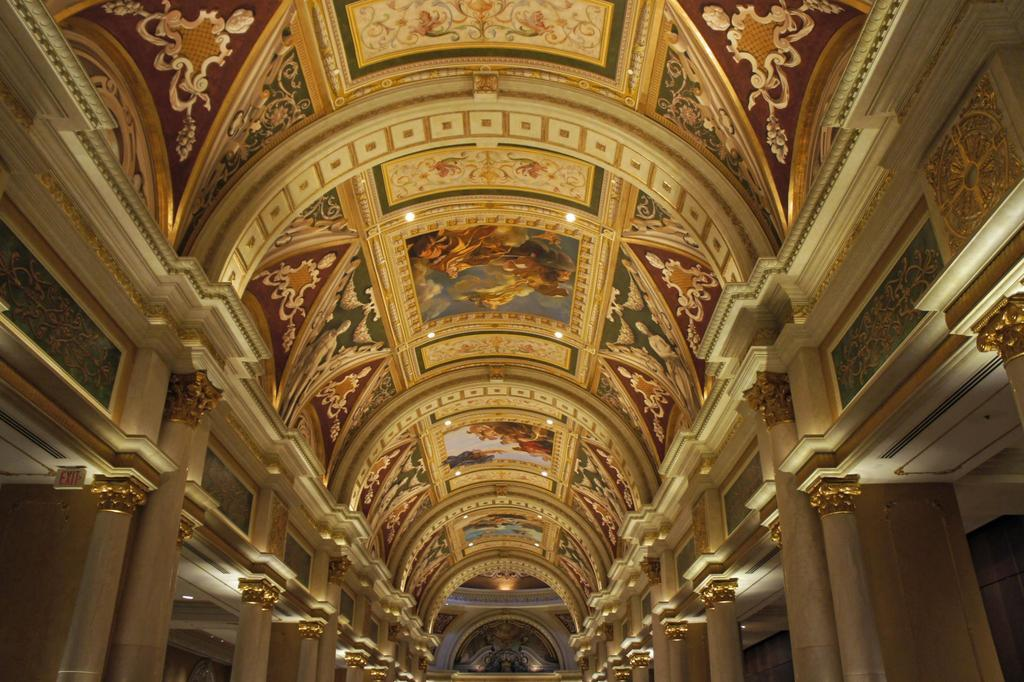What can be seen at the top of the image? There are lights visible at the top of the image. What is depicted on a wall in the image? There is a drawing on a wall in the image. What type of mountain is visible in the image? There is no mountain present in the image. What thoughts are being expressed by the drawing on the wall? The drawing on the wall does not express any thoughts, as it is an image and not a form of communication. 